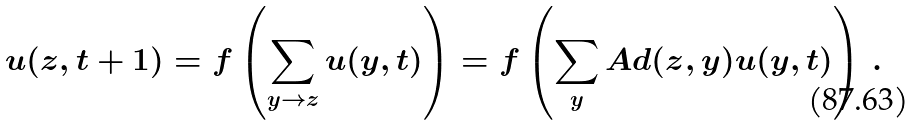<formula> <loc_0><loc_0><loc_500><loc_500>u ( z , t + 1 ) = f \left ( \sum _ { y \rightarrow z } u ( y , t ) \right ) = f \left ( \sum _ { y } A d ( z , y ) u ( y , t ) \right ) \, .</formula> 